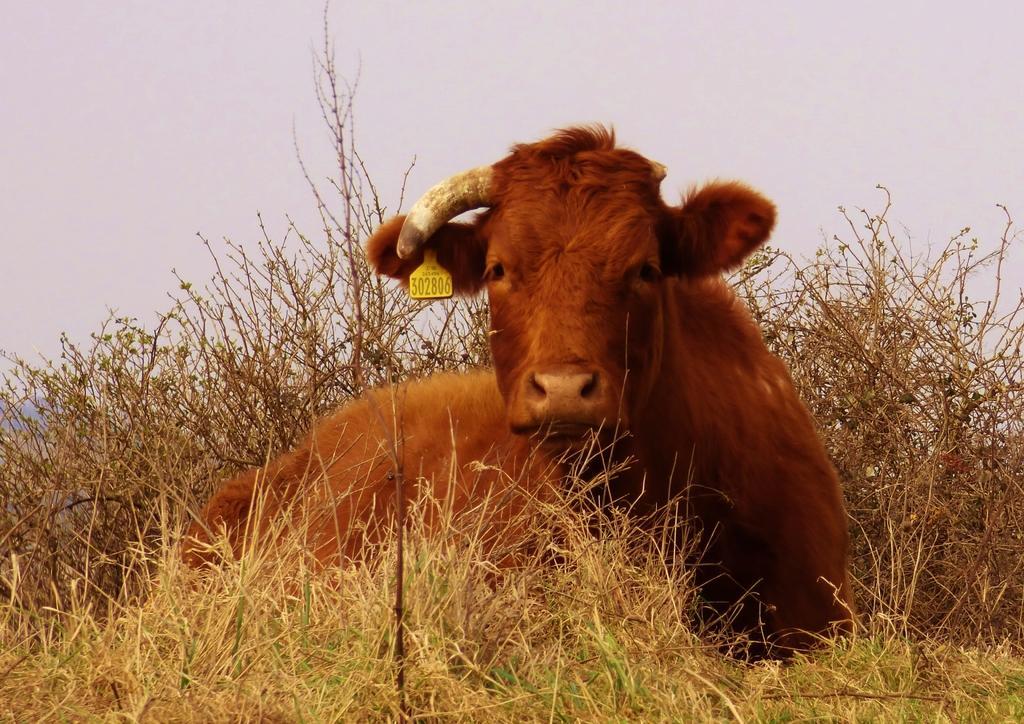In one or two sentences, can you explain what this image depicts? In this picture there is an animal sitting. At the top there is sky. At the bottom there is grass and the animal is in brown color. 